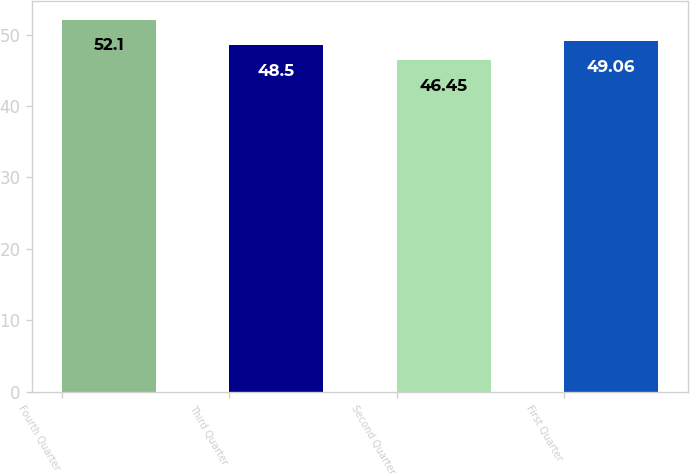<chart> <loc_0><loc_0><loc_500><loc_500><bar_chart><fcel>Fourth Quarter<fcel>Third Quarter<fcel>Second Quarter<fcel>First Quarter<nl><fcel>52.1<fcel>48.5<fcel>46.45<fcel>49.06<nl></chart> 